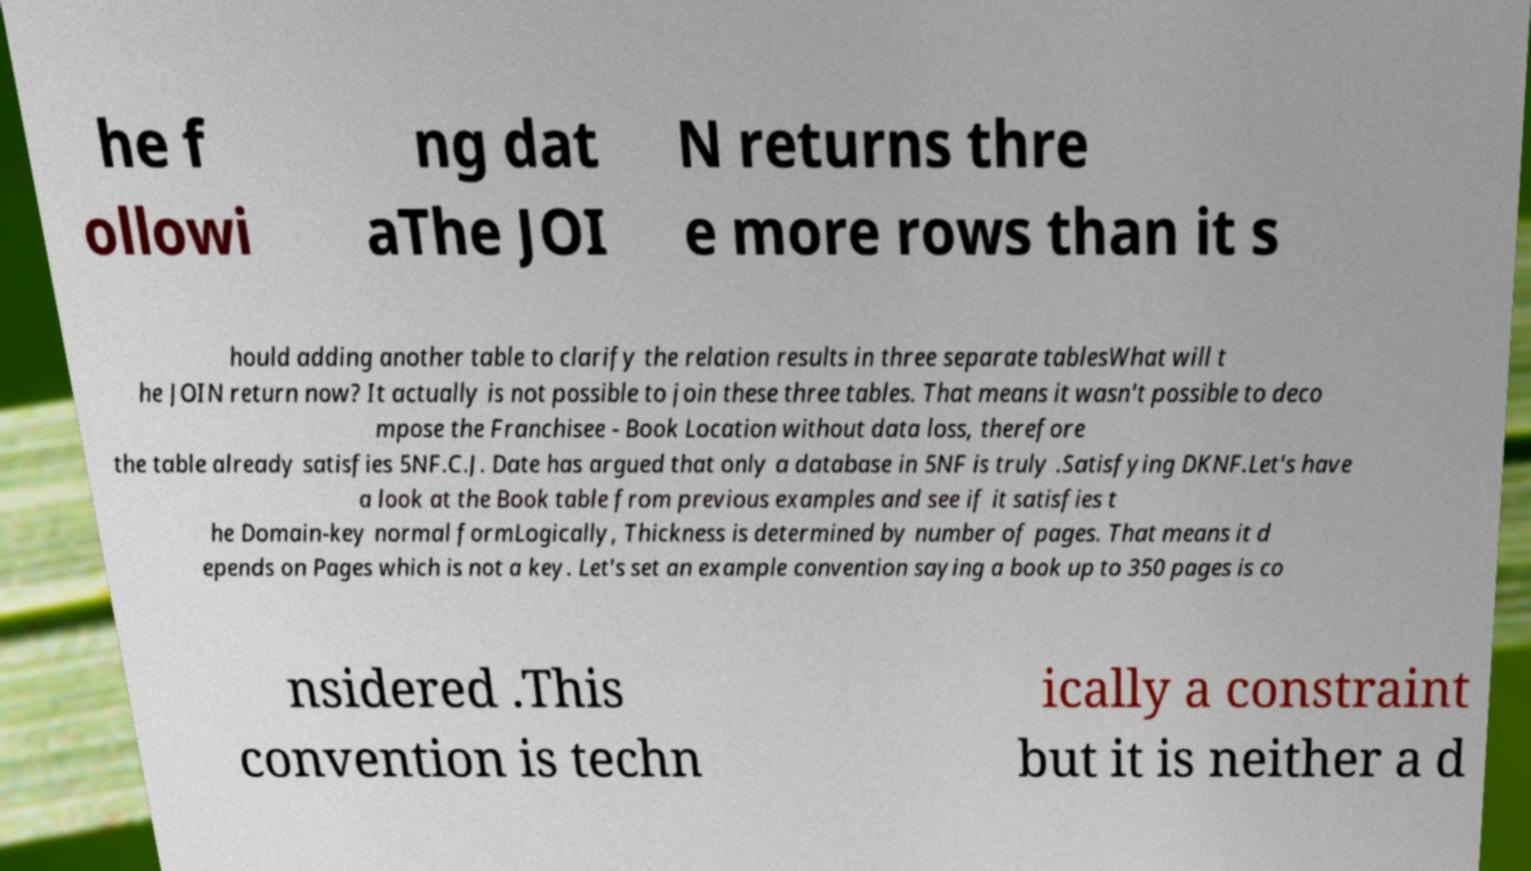Could you assist in decoding the text presented in this image and type it out clearly? he f ollowi ng dat aThe JOI N returns thre e more rows than it s hould adding another table to clarify the relation results in three separate tablesWhat will t he JOIN return now? It actually is not possible to join these three tables. That means it wasn't possible to deco mpose the Franchisee - Book Location without data loss, therefore the table already satisfies 5NF.C.J. Date has argued that only a database in 5NF is truly .Satisfying DKNF.Let's have a look at the Book table from previous examples and see if it satisfies t he Domain-key normal formLogically, Thickness is determined by number of pages. That means it d epends on Pages which is not a key. Let's set an example convention saying a book up to 350 pages is co nsidered .This convention is techn ically a constraint but it is neither a d 